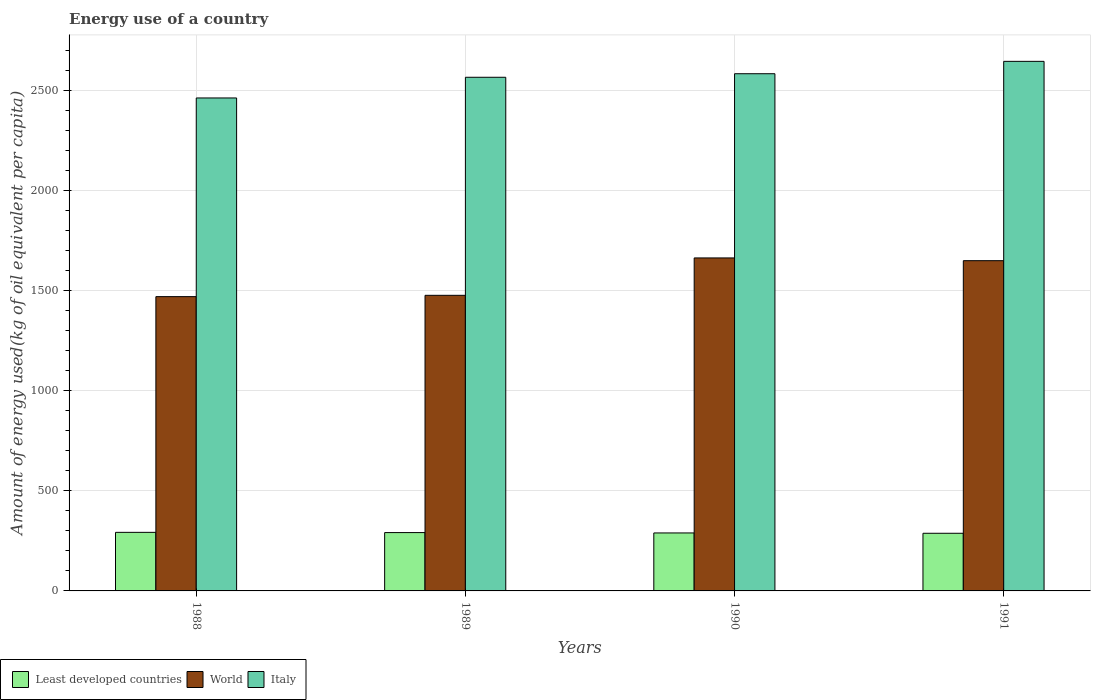How many different coloured bars are there?
Keep it short and to the point. 3. How many groups of bars are there?
Give a very brief answer. 4. Are the number of bars per tick equal to the number of legend labels?
Offer a very short reply. Yes. How many bars are there on the 1st tick from the left?
Offer a very short reply. 3. How many bars are there on the 1st tick from the right?
Offer a terse response. 3. What is the label of the 4th group of bars from the left?
Your response must be concise. 1991. In how many cases, is the number of bars for a given year not equal to the number of legend labels?
Your answer should be very brief. 0. What is the amount of energy used in in Italy in 1990?
Provide a short and direct response. 2583.89. Across all years, what is the maximum amount of energy used in in World?
Make the answer very short. 1663.58. Across all years, what is the minimum amount of energy used in in World?
Keep it short and to the point. 1470.27. In which year was the amount of energy used in in Italy maximum?
Offer a terse response. 1991. What is the total amount of energy used in in Italy in the graph?
Offer a very short reply. 1.03e+04. What is the difference between the amount of energy used in in Least developed countries in 1988 and that in 1989?
Your response must be concise. 1.18. What is the difference between the amount of energy used in in Least developed countries in 1989 and the amount of energy used in in World in 1991?
Keep it short and to the point. -1358.44. What is the average amount of energy used in in World per year?
Offer a terse response. 1565.12. In the year 1990, what is the difference between the amount of energy used in in Least developed countries and amount of energy used in in Italy?
Your answer should be compact. -2294.21. What is the ratio of the amount of energy used in in Italy in 1988 to that in 1991?
Your response must be concise. 0.93. Is the amount of energy used in in World in 1989 less than that in 1990?
Provide a short and direct response. Yes. Is the difference between the amount of energy used in in Least developed countries in 1990 and 1991 greater than the difference between the amount of energy used in in Italy in 1990 and 1991?
Your response must be concise. Yes. What is the difference between the highest and the second highest amount of energy used in in Italy?
Offer a terse response. 61.79. What is the difference between the highest and the lowest amount of energy used in in Least developed countries?
Offer a very short reply. 4.6. In how many years, is the amount of energy used in in Italy greater than the average amount of energy used in in Italy taken over all years?
Your answer should be compact. 3. Is the sum of the amount of energy used in in Least developed countries in 1989 and 1991 greater than the maximum amount of energy used in in Italy across all years?
Provide a succinct answer. No. What is the difference between two consecutive major ticks on the Y-axis?
Keep it short and to the point. 500. Does the graph contain any zero values?
Give a very brief answer. No. How many legend labels are there?
Your response must be concise. 3. How are the legend labels stacked?
Ensure brevity in your answer.  Horizontal. What is the title of the graph?
Make the answer very short. Energy use of a country. Does "Low & middle income" appear as one of the legend labels in the graph?
Offer a terse response. No. What is the label or title of the Y-axis?
Your answer should be very brief. Amount of energy used(kg of oil equivalent per capita). What is the Amount of energy used(kg of oil equivalent per capita) of Least developed countries in 1988?
Provide a short and direct response. 292.6. What is the Amount of energy used(kg of oil equivalent per capita) of World in 1988?
Make the answer very short. 1470.27. What is the Amount of energy used(kg of oil equivalent per capita) in Italy in 1988?
Your response must be concise. 2462.8. What is the Amount of energy used(kg of oil equivalent per capita) in Least developed countries in 1989?
Provide a short and direct response. 291.43. What is the Amount of energy used(kg of oil equivalent per capita) in World in 1989?
Make the answer very short. 1476.77. What is the Amount of energy used(kg of oil equivalent per capita) of Italy in 1989?
Give a very brief answer. 2566.11. What is the Amount of energy used(kg of oil equivalent per capita) of Least developed countries in 1990?
Your answer should be very brief. 289.68. What is the Amount of energy used(kg of oil equivalent per capita) in World in 1990?
Your answer should be compact. 1663.58. What is the Amount of energy used(kg of oil equivalent per capita) in Italy in 1990?
Offer a terse response. 2583.89. What is the Amount of energy used(kg of oil equivalent per capita) in Least developed countries in 1991?
Your response must be concise. 288.01. What is the Amount of energy used(kg of oil equivalent per capita) in World in 1991?
Keep it short and to the point. 1649.87. What is the Amount of energy used(kg of oil equivalent per capita) of Italy in 1991?
Your response must be concise. 2645.67. Across all years, what is the maximum Amount of energy used(kg of oil equivalent per capita) of Least developed countries?
Your answer should be compact. 292.6. Across all years, what is the maximum Amount of energy used(kg of oil equivalent per capita) of World?
Make the answer very short. 1663.58. Across all years, what is the maximum Amount of energy used(kg of oil equivalent per capita) in Italy?
Provide a succinct answer. 2645.67. Across all years, what is the minimum Amount of energy used(kg of oil equivalent per capita) of Least developed countries?
Your answer should be compact. 288.01. Across all years, what is the minimum Amount of energy used(kg of oil equivalent per capita) in World?
Ensure brevity in your answer.  1470.27. Across all years, what is the minimum Amount of energy used(kg of oil equivalent per capita) of Italy?
Give a very brief answer. 2462.8. What is the total Amount of energy used(kg of oil equivalent per capita) in Least developed countries in the graph?
Make the answer very short. 1161.71. What is the total Amount of energy used(kg of oil equivalent per capita) of World in the graph?
Provide a short and direct response. 6260.48. What is the total Amount of energy used(kg of oil equivalent per capita) of Italy in the graph?
Your response must be concise. 1.03e+04. What is the difference between the Amount of energy used(kg of oil equivalent per capita) of Least developed countries in 1988 and that in 1989?
Offer a very short reply. 1.18. What is the difference between the Amount of energy used(kg of oil equivalent per capita) in World in 1988 and that in 1989?
Ensure brevity in your answer.  -6.5. What is the difference between the Amount of energy used(kg of oil equivalent per capita) in Italy in 1988 and that in 1989?
Your answer should be very brief. -103.31. What is the difference between the Amount of energy used(kg of oil equivalent per capita) in Least developed countries in 1988 and that in 1990?
Provide a short and direct response. 2.93. What is the difference between the Amount of energy used(kg of oil equivalent per capita) of World in 1988 and that in 1990?
Offer a very short reply. -193.3. What is the difference between the Amount of energy used(kg of oil equivalent per capita) in Italy in 1988 and that in 1990?
Your answer should be very brief. -121.09. What is the difference between the Amount of energy used(kg of oil equivalent per capita) of Least developed countries in 1988 and that in 1991?
Make the answer very short. 4.6. What is the difference between the Amount of energy used(kg of oil equivalent per capita) of World in 1988 and that in 1991?
Provide a succinct answer. -179.59. What is the difference between the Amount of energy used(kg of oil equivalent per capita) in Italy in 1988 and that in 1991?
Ensure brevity in your answer.  -182.88. What is the difference between the Amount of energy used(kg of oil equivalent per capita) in Least developed countries in 1989 and that in 1990?
Keep it short and to the point. 1.75. What is the difference between the Amount of energy used(kg of oil equivalent per capita) of World in 1989 and that in 1990?
Offer a terse response. -186.81. What is the difference between the Amount of energy used(kg of oil equivalent per capita) of Italy in 1989 and that in 1990?
Keep it short and to the point. -17.78. What is the difference between the Amount of energy used(kg of oil equivalent per capita) in Least developed countries in 1989 and that in 1991?
Your answer should be compact. 3.42. What is the difference between the Amount of energy used(kg of oil equivalent per capita) in World in 1989 and that in 1991?
Your answer should be very brief. -173.1. What is the difference between the Amount of energy used(kg of oil equivalent per capita) in Italy in 1989 and that in 1991?
Your answer should be compact. -79.56. What is the difference between the Amount of energy used(kg of oil equivalent per capita) of Least developed countries in 1990 and that in 1991?
Make the answer very short. 1.67. What is the difference between the Amount of energy used(kg of oil equivalent per capita) of World in 1990 and that in 1991?
Offer a terse response. 13.71. What is the difference between the Amount of energy used(kg of oil equivalent per capita) of Italy in 1990 and that in 1991?
Ensure brevity in your answer.  -61.79. What is the difference between the Amount of energy used(kg of oil equivalent per capita) of Least developed countries in 1988 and the Amount of energy used(kg of oil equivalent per capita) of World in 1989?
Make the answer very short. -1184.16. What is the difference between the Amount of energy used(kg of oil equivalent per capita) of Least developed countries in 1988 and the Amount of energy used(kg of oil equivalent per capita) of Italy in 1989?
Provide a succinct answer. -2273.51. What is the difference between the Amount of energy used(kg of oil equivalent per capita) of World in 1988 and the Amount of energy used(kg of oil equivalent per capita) of Italy in 1989?
Ensure brevity in your answer.  -1095.84. What is the difference between the Amount of energy used(kg of oil equivalent per capita) of Least developed countries in 1988 and the Amount of energy used(kg of oil equivalent per capita) of World in 1990?
Provide a short and direct response. -1370.97. What is the difference between the Amount of energy used(kg of oil equivalent per capita) of Least developed countries in 1988 and the Amount of energy used(kg of oil equivalent per capita) of Italy in 1990?
Your answer should be compact. -2291.29. What is the difference between the Amount of energy used(kg of oil equivalent per capita) in World in 1988 and the Amount of energy used(kg of oil equivalent per capita) in Italy in 1990?
Provide a succinct answer. -1113.62. What is the difference between the Amount of energy used(kg of oil equivalent per capita) in Least developed countries in 1988 and the Amount of energy used(kg of oil equivalent per capita) in World in 1991?
Give a very brief answer. -1357.26. What is the difference between the Amount of energy used(kg of oil equivalent per capita) in Least developed countries in 1988 and the Amount of energy used(kg of oil equivalent per capita) in Italy in 1991?
Provide a succinct answer. -2353.07. What is the difference between the Amount of energy used(kg of oil equivalent per capita) of World in 1988 and the Amount of energy used(kg of oil equivalent per capita) of Italy in 1991?
Your response must be concise. -1175.4. What is the difference between the Amount of energy used(kg of oil equivalent per capita) of Least developed countries in 1989 and the Amount of energy used(kg of oil equivalent per capita) of World in 1990?
Offer a terse response. -1372.15. What is the difference between the Amount of energy used(kg of oil equivalent per capita) in Least developed countries in 1989 and the Amount of energy used(kg of oil equivalent per capita) in Italy in 1990?
Offer a terse response. -2292.46. What is the difference between the Amount of energy used(kg of oil equivalent per capita) in World in 1989 and the Amount of energy used(kg of oil equivalent per capita) in Italy in 1990?
Make the answer very short. -1107.12. What is the difference between the Amount of energy used(kg of oil equivalent per capita) of Least developed countries in 1989 and the Amount of energy used(kg of oil equivalent per capita) of World in 1991?
Give a very brief answer. -1358.44. What is the difference between the Amount of energy used(kg of oil equivalent per capita) of Least developed countries in 1989 and the Amount of energy used(kg of oil equivalent per capita) of Italy in 1991?
Your answer should be very brief. -2354.25. What is the difference between the Amount of energy used(kg of oil equivalent per capita) of World in 1989 and the Amount of energy used(kg of oil equivalent per capita) of Italy in 1991?
Make the answer very short. -1168.91. What is the difference between the Amount of energy used(kg of oil equivalent per capita) in Least developed countries in 1990 and the Amount of energy used(kg of oil equivalent per capita) in World in 1991?
Offer a very short reply. -1360.19. What is the difference between the Amount of energy used(kg of oil equivalent per capita) of Least developed countries in 1990 and the Amount of energy used(kg of oil equivalent per capita) of Italy in 1991?
Keep it short and to the point. -2356. What is the difference between the Amount of energy used(kg of oil equivalent per capita) of World in 1990 and the Amount of energy used(kg of oil equivalent per capita) of Italy in 1991?
Provide a short and direct response. -982.1. What is the average Amount of energy used(kg of oil equivalent per capita) of Least developed countries per year?
Give a very brief answer. 290.43. What is the average Amount of energy used(kg of oil equivalent per capita) of World per year?
Make the answer very short. 1565.12. What is the average Amount of energy used(kg of oil equivalent per capita) in Italy per year?
Make the answer very short. 2564.62. In the year 1988, what is the difference between the Amount of energy used(kg of oil equivalent per capita) of Least developed countries and Amount of energy used(kg of oil equivalent per capita) of World?
Provide a short and direct response. -1177.67. In the year 1988, what is the difference between the Amount of energy used(kg of oil equivalent per capita) of Least developed countries and Amount of energy used(kg of oil equivalent per capita) of Italy?
Ensure brevity in your answer.  -2170.19. In the year 1988, what is the difference between the Amount of energy used(kg of oil equivalent per capita) of World and Amount of energy used(kg of oil equivalent per capita) of Italy?
Your response must be concise. -992.52. In the year 1989, what is the difference between the Amount of energy used(kg of oil equivalent per capita) in Least developed countries and Amount of energy used(kg of oil equivalent per capita) in World?
Offer a terse response. -1185.34. In the year 1989, what is the difference between the Amount of energy used(kg of oil equivalent per capita) of Least developed countries and Amount of energy used(kg of oil equivalent per capita) of Italy?
Provide a short and direct response. -2274.68. In the year 1989, what is the difference between the Amount of energy used(kg of oil equivalent per capita) in World and Amount of energy used(kg of oil equivalent per capita) in Italy?
Your response must be concise. -1089.34. In the year 1990, what is the difference between the Amount of energy used(kg of oil equivalent per capita) in Least developed countries and Amount of energy used(kg of oil equivalent per capita) in World?
Offer a terse response. -1373.9. In the year 1990, what is the difference between the Amount of energy used(kg of oil equivalent per capita) in Least developed countries and Amount of energy used(kg of oil equivalent per capita) in Italy?
Keep it short and to the point. -2294.21. In the year 1990, what is the difference between the Amount of energy used(kg of oil equivalent per capita) of World and Amount of energy used(kg of oil equivalent per capita) of Italy?
Make the answer very short. -920.31. In the year 1991, what is the difference between the Amount of energy used(kg of oil equivalent per capita) of Least developed countries and Amount of energy used(kg of oil equivalent per capita) of World?
Your answer should be very brief. -1361.86. In the year 1991, what is the difference between the Amount of energy used(kg of oil equivalent per capita) in Least developed countries and Amount of energy used(kg of oil equivalent per capita) in Italy?
Give a very brief answer. -2357.67. In the year 1991, what is the difference between the Amount of energy used(kg of oil equivalent per capita) of World and Amount of energy used(kg of oil equivalent per capita) of Italy?
Give a very brief answer. -995.81. What is the ratio of the Amount of energy used(kg of oil equivalent per capita) in Italy in 1988 to that in 1989?
Ensure brevity in your answer.  0.96. What is the ratio of the Amount of energy used(kg of oil equivalent per capita) in World in 1988 to that in 1990?
Offer a terse response. 0.88. What is the ratio of the Amount of energy used(kg of oil equivalent per capita) of Italy in 1988 to that in 1990?
Make the answer very short. 0.95. What is the ratio of the Amount of energy used(kg of oil equivalent per capita) of Least developed countries in 1988 to that in 1991?
Provide a short and direct response. 1.02. What is the ratio of the Amount of energy used(kg of oil equivalent per capita) in World in 1988 to that in 1991?
Offer a terse response. 0.89. What is the ratio of the Amount of energy used(kg of oil equivalent per capita) in Italy in 1988 to that in 1991?
Give a very brief answer. 0.93. What is the ratio of the Amount of energy used(kg of oil equivalent per capita) in Least developed countries in 1989 to that in 1990?
Give a very brief answer. 1.01. What is the ratio of the Amount of energy used(kg of oil equivalent per capita) of World in 1989 to that in 1990?
Provide a succinct answer. 0.89. What is the ratio of the Amount of energy used(kg of oil equivalent per capita) of Italy in 1989 to that in 1990?
Offer a terse response. 0.99. What is the ratio of the Amount of energy used(kg of oil equivalent per capita) in Least developed countries in 1989 to that in 1991?
Give a very brief answer. 1.01. What is the ratio of the Amount of energy used(kg of oil equivalent per capita) in World in 1989 to that in 1991?
Give a very brief answer. 0.9. What is the ratio of the Amount of energy used(kg of oil equivalent per capita) in Italy in 1989 to that in 1991?
Give a very brief answer. 0.97. What is the ratio of the Amount of energy used(kg of oil equivalent per capita) of Least developed countries in 1990 to that in 1991?
Make the answer very short. 1.01. What is the ratio of the Amount of energy used(kg of oil equivalent per capita) in World in 1990 to that in 1991?
Give a very brief answer. 1.01. What is the ratio of the Amount of energy used(kg of oil equivalent per capita) in Italy in 1990 to that in 1991?
Your response must be concise. 0.98. What is the difference between the highest and the second highest Amount of energy used(kg of oil equivalent per capita) in Least developed countries?
Your answer should be compact. 1.18. What is the difference between the highest and the second highest Amount of energy used(kg of oil equivalent per capita) in World?
Keep it short and to the point. 13.71. What is the difference between the highest and the second highest Amount of energy used(kg of oil equivalent per capita) of Italy?
Ensure brevity in your answer.  61.79. What is the difference between the highest and the lowest Amount of energy used(kg of oil equivalent per capita) in Least developed countries?
Ensure brevity in your answer.  4.6. What is the difference between the highest and the lowest Amount of energy used(kg of oil equivalent per capita) of World?
Provide a succinct answer. 193.3. What is the difference between the highest and the lowest Amount of energy used(kg of oil equivalent per capita) of Italy?
Your answer should be very brief. 182.88. 